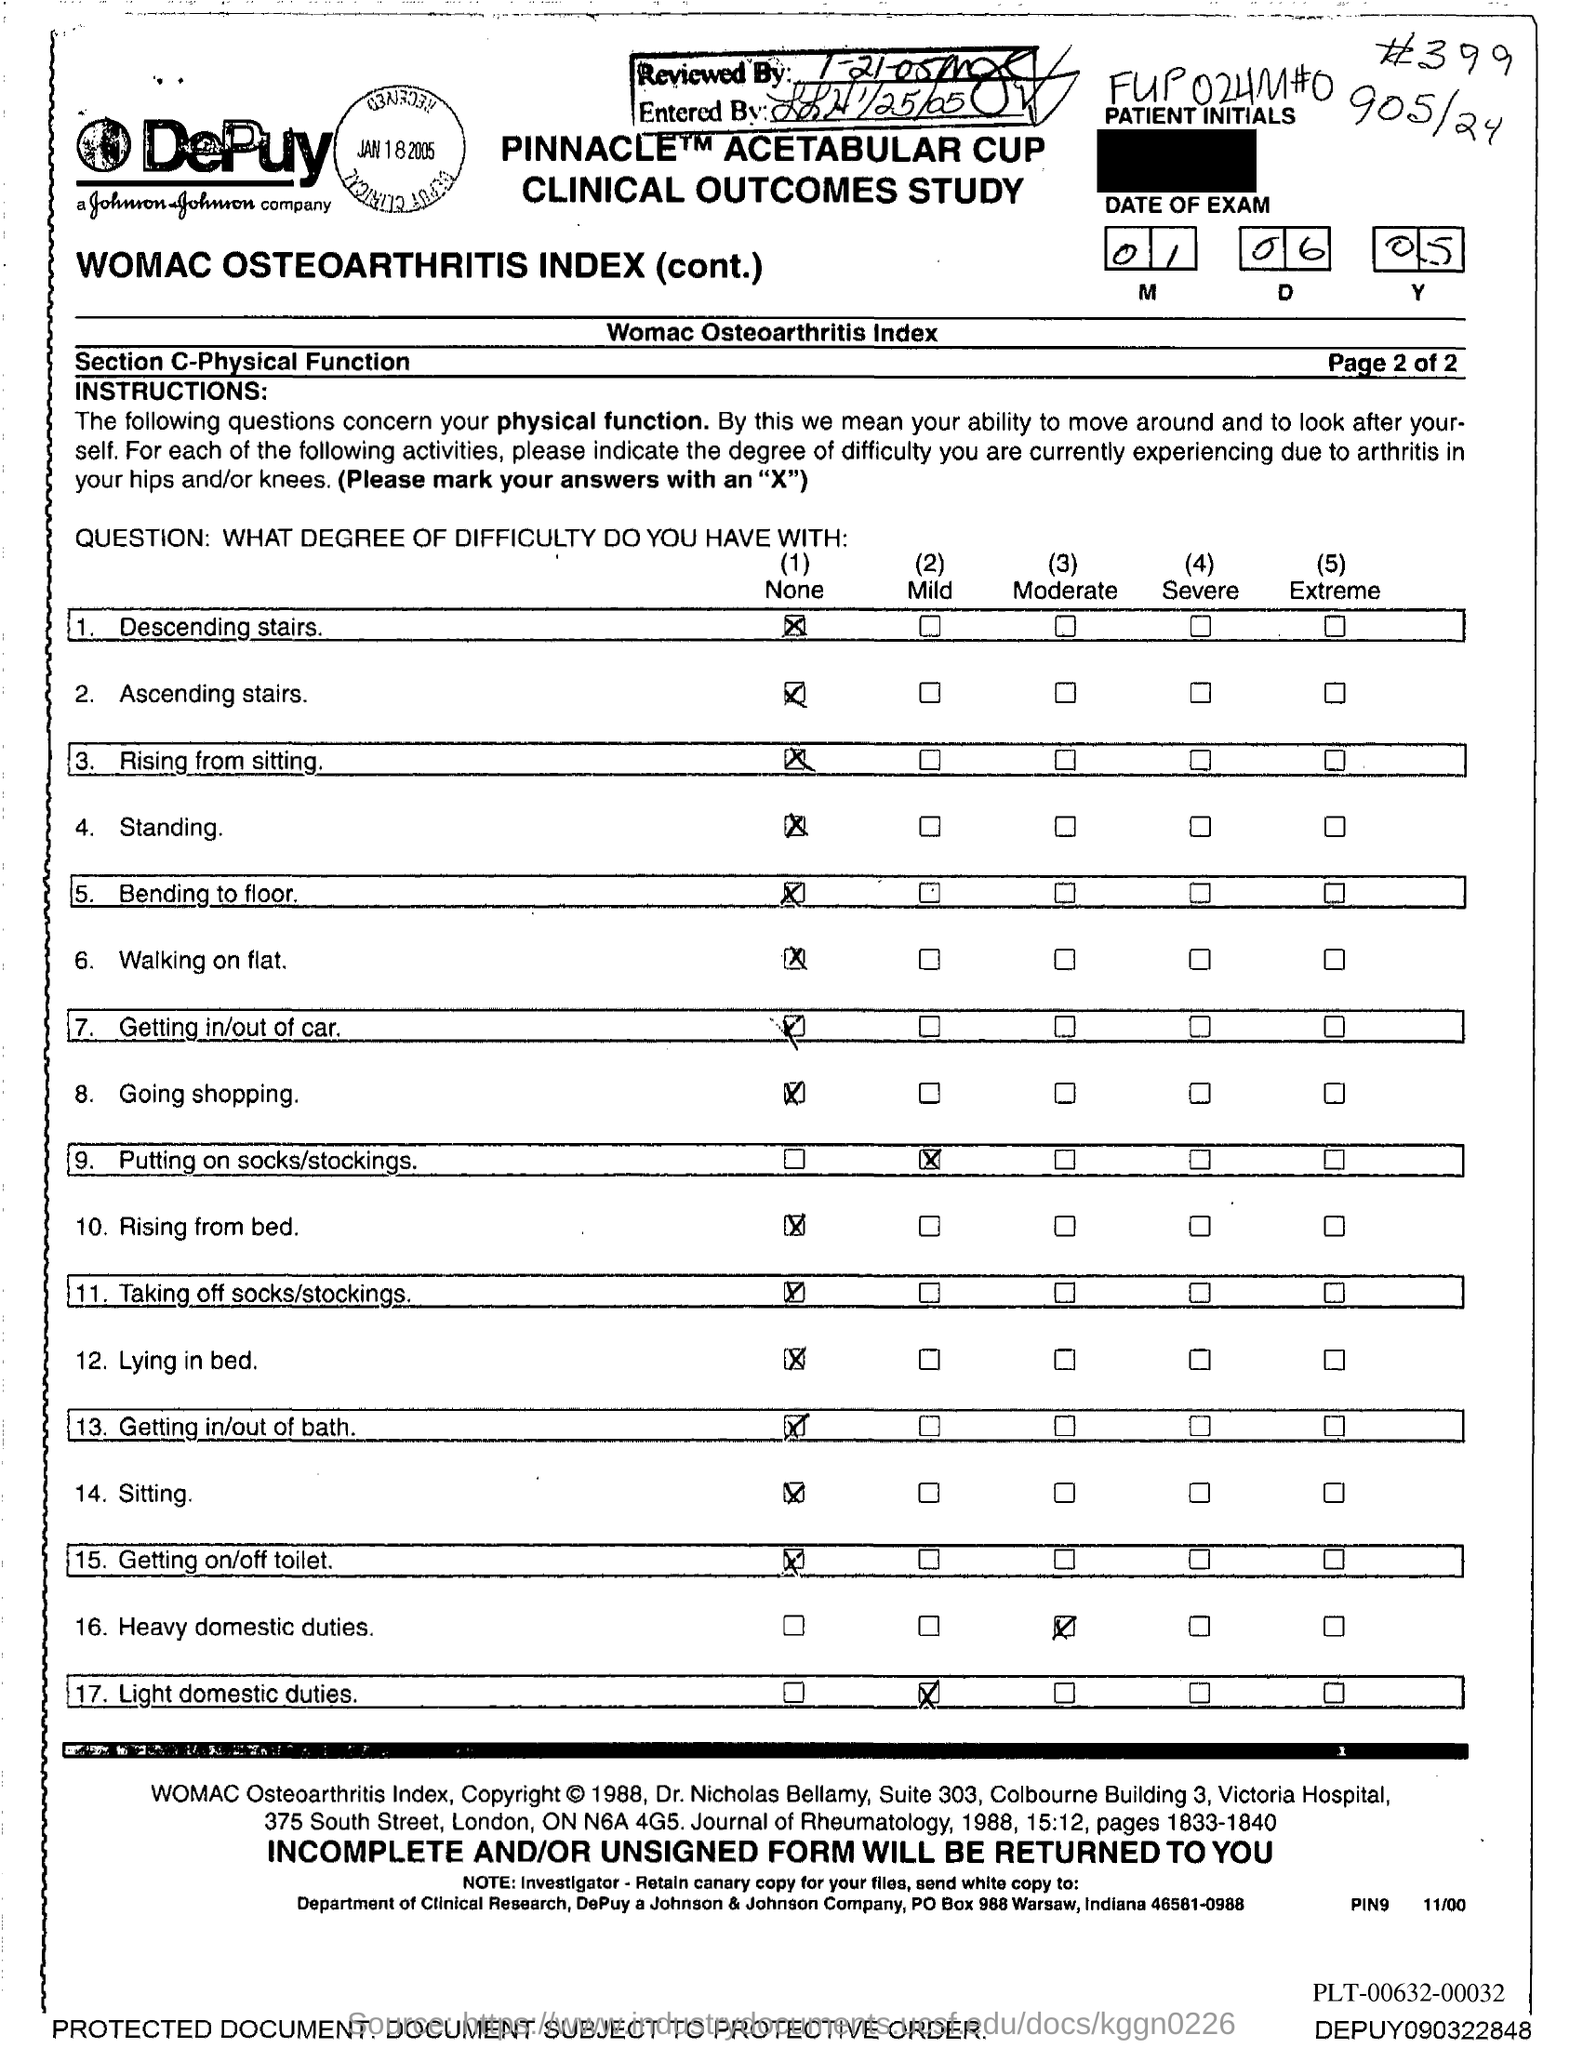What is the Reviewed date mentioned in the document?
Keep it short and to the point. 1-21-05. What is the Entered date mentioned in the document?
Your answer should be very brief. 1/25/05. 